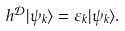Convert formula to latex. <formula><loc_0><loc_0><loc_500><loc_500>h ^ { \mathcal { D } } | \psi _ { k } \rangle = \varepsilon _ { k } | \psi _ { k } \rangle .</formula> 